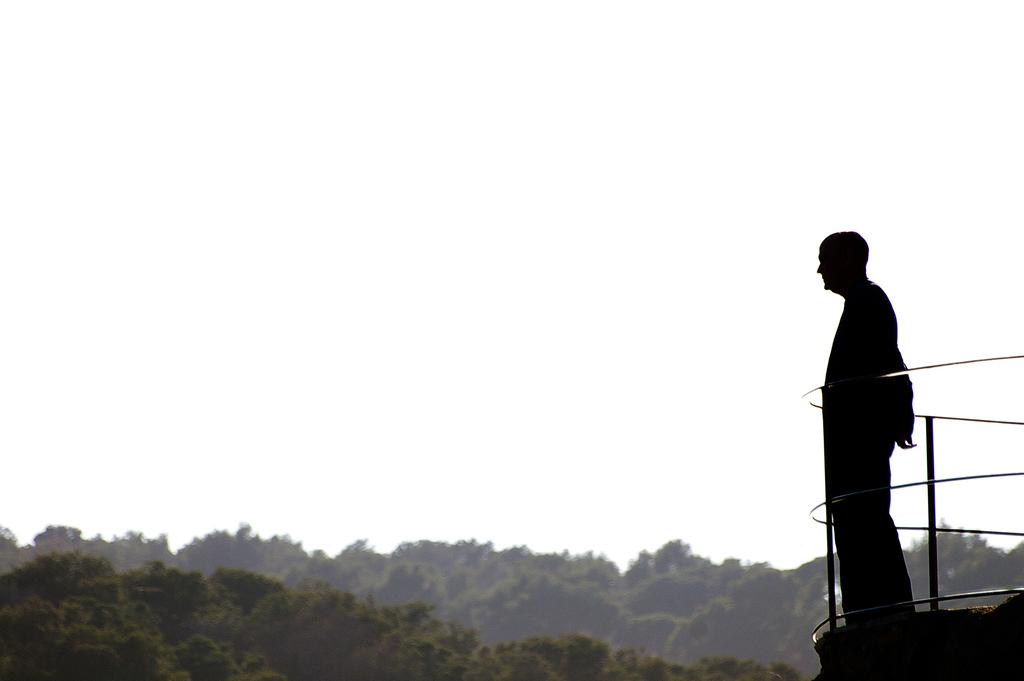What is the main subject of the image? There is a person standing in the image. What object can be seen behind the person? There is an iron grill in the image. What type of vegetation is visible in the image? There are trees with branches and leaves in the image. What color are the eggs on the branches of the trees in the image? There are no eggs present on the branches of the trees in the image. Can you describe the texture of the feathers on the person's clothing in the image? There are no feathers visible on the person's clothing in the image. 